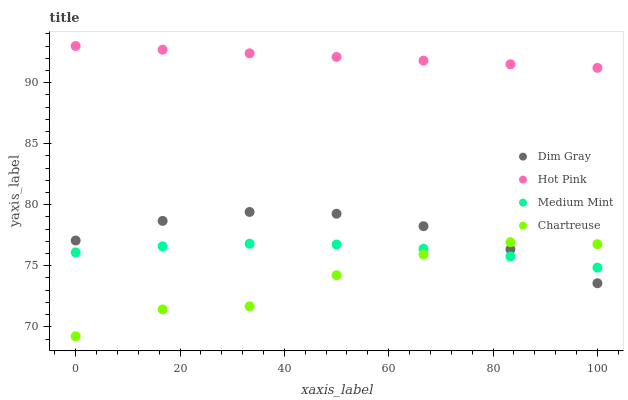Does Chartreuse have the minimum area under the curve?
Answer yes or no. Yes. Does Hot Pink have the maximum area under the curve?
Answer yes or no. Yes. Does Dim Gray have the minimum area under the curve?
Answer yes or no. No. Does Dim Gray have the maximum area under the curve?
Answer yes or no. No. Is Hot Pink the smoothest?
Answer yes or no. Yes. Is Chartreuse the roughest?
Answer yes or no. Yes. Is Dim Gray the smoothest?
Answer yes or no. No. Is Dim Gray the roughest?
Answer yes or no. No. Does Chartreuse have the lowest value?
Answer yes or no. Yes. Does Dim Gray have the lowest value?
Answer yes or no. No. Does Hot Pink have the highest value?
Answer yes or no. Yes. Does Chartreuse have the highest value?
Answer yes or no. No. Is Medium Mint less than Hot Pink?
Answer yes or no. Yes. Is Hot Pink greater than Chartreuse?
Answer yes or no. Yes. Does Medium Mint intersect Dim Gray?
Answer yes or no. Yes. Is Medium Mint less than Dim Gray?
Answer yes or no. No. Is Medium Mint greater than Dim Gray?
Answer yes or no. No. Does Medium Mint intersect Hot Pink?
Answer yes or no. No. 